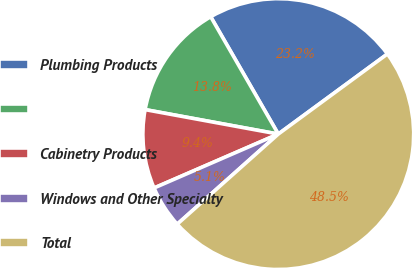Convert chart to OTSL. <chart><loc_0><loc_0><loc_500><loc_500><pie_chart><fcel>Plumbing Products<fcel>Unnamed: 1<fcel>Cabinetry Products<fcel>Windows and Other Specialty<fcel>Total<nl><fcel>23.24%<fcel>13.79%<fcel>9.41%<fcel>5.07%<fcel>48.49%<nl></chart> 